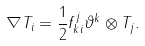Convert formula to latex. <formula><loc_0><loc_0><loc_500><loc_500>\nabla T _ { i } = \frac { 1 } { 2 } f _ { k i } ^ { j } \vartheta ^ { k } \otimes T _ { j } .</formula> 